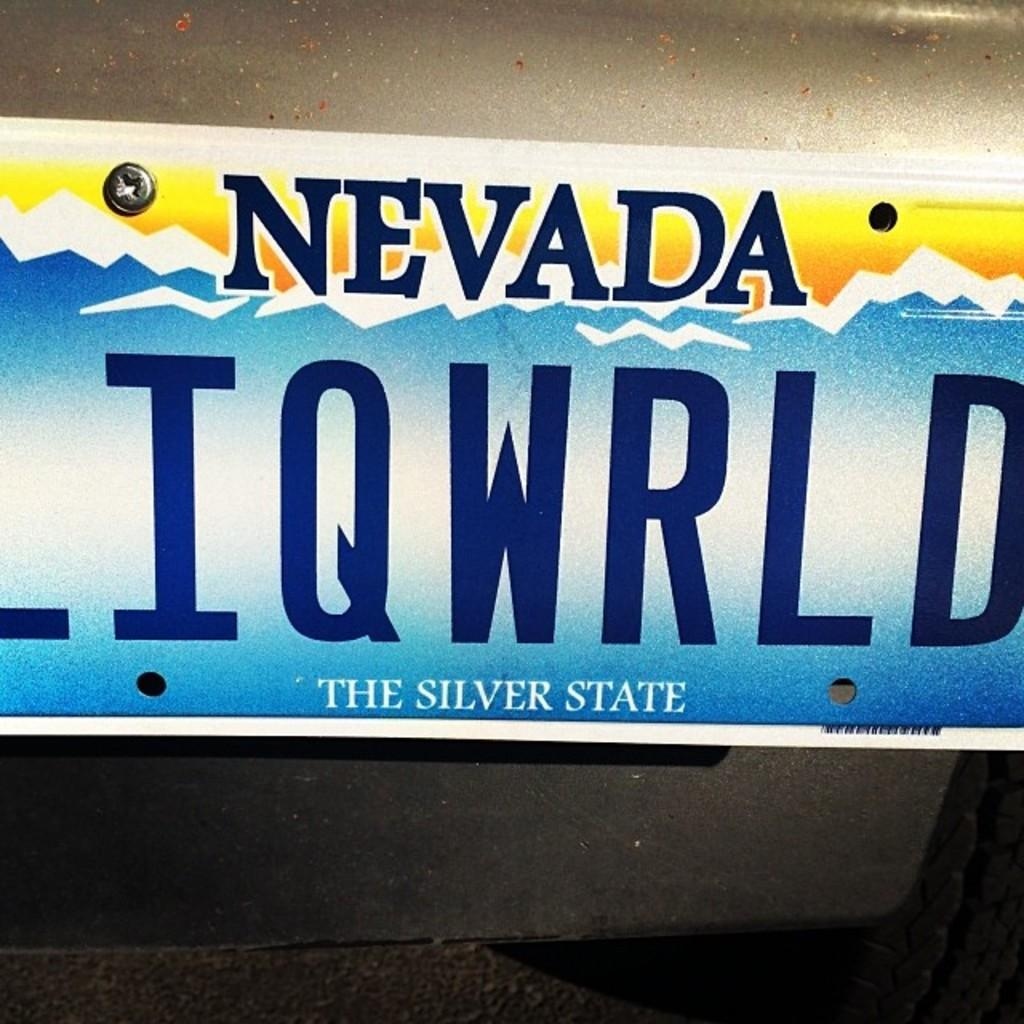<image>
Offer a succinct explanation of the picture presented. a license plate says Navada the silvers state 